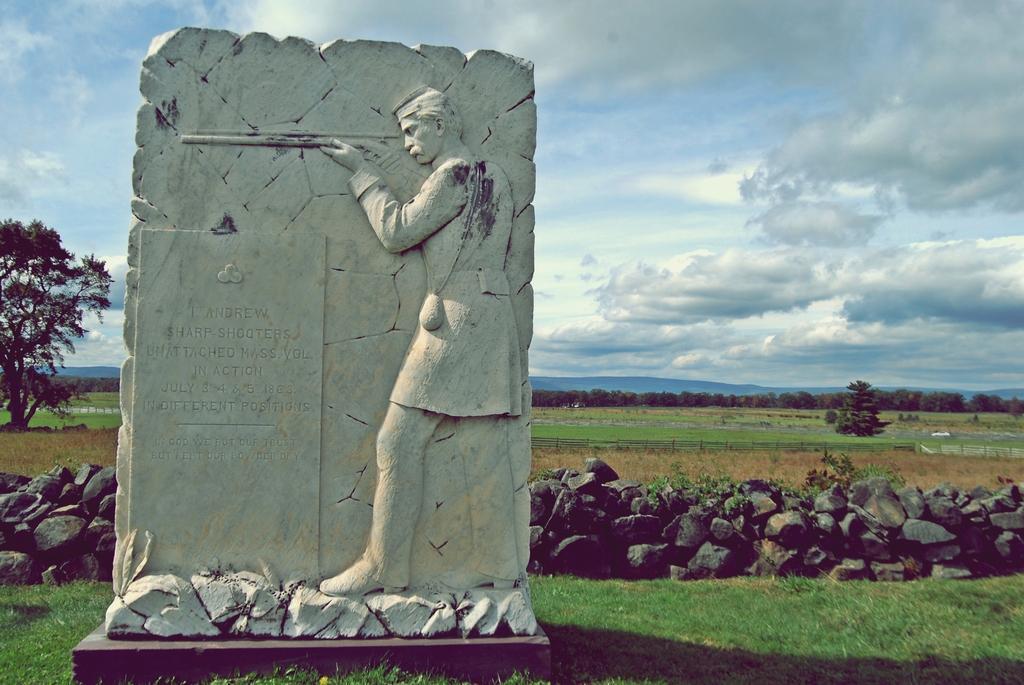Can you describe this image briefly? In this picture we can see a stone sculpture on the path and behind the sculpture there are stones, trees, hills and a cloudy sky. 